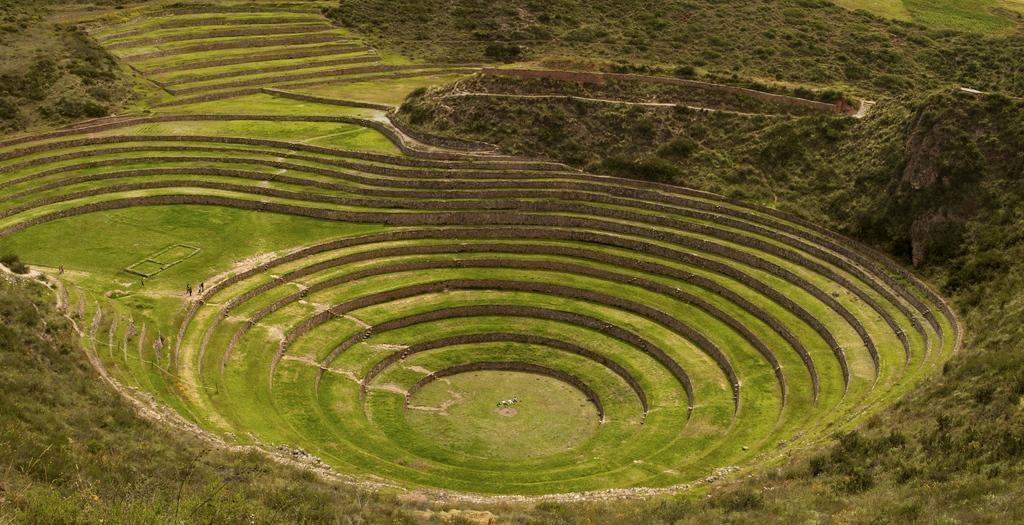What type of farming is shown in the image? The image depicts step farming. What can be seen growing in the image? There are plants in the image. What type of vegetation is present in the image? There are trees in the image. What type of tools does the carpenter use in the image? There is no carpenter present in the image; it depicts step farming with plants and trees. What direction is the mountain facing in the image? There is no mountain present in the image; it depicts step farming on-level step farming with plants and trees. 